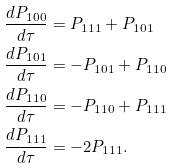<formula> <loc_0><loc_0><loc_500><loc_500>\frac { d P _ { 1 0 0 } } { d \tau } & = P _ { 1 1 1 } + P _ { 1 0 1 } \\ \frac { d P _ { 1 0 1 } } { d \tau } & = - P _ { 1 0 1 } + P _ { 1 1 0 } \\ \frac { d P _ { 1 1 0 } } { d \tau } & = - P _ { 1 1 0 } + P _ { 1 1 1 } \\ \frac { d P _ { 1 1 1 } } { d \tau } & = - 2 P _ { 1 1 1 } .</formula> 